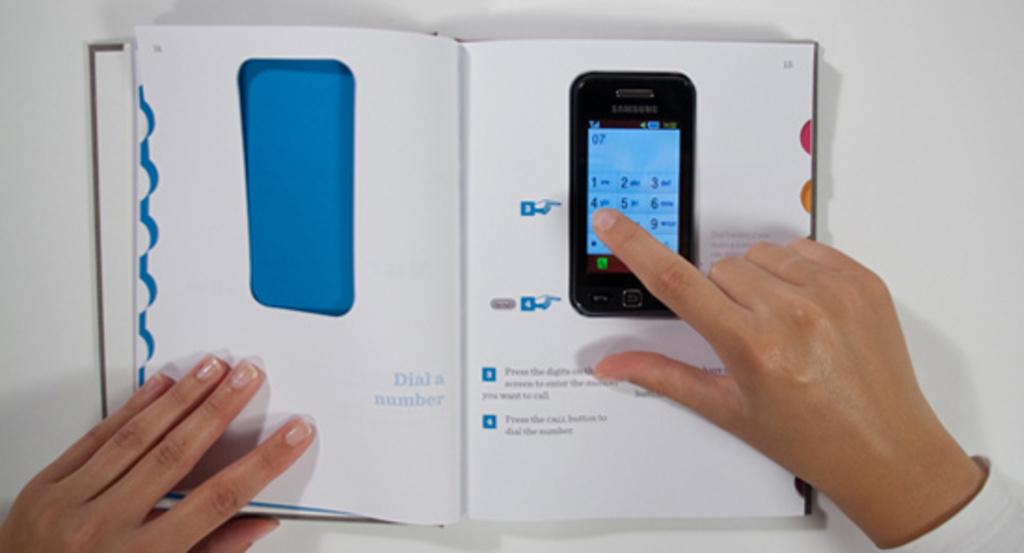<image>
Offer a succinct explanation of the picture presented. A person is reading a book about a cell phone and pointing to the button that says 4. 